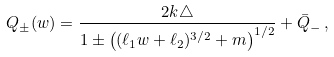<formula> <loc_0><loc_0><loc_500><loc_500>Q _ { \pm } ( w ) = \frac { 2 k \triangle } { 1 \pm \left ( ( \ell _ { 1 } w + \ell _ { 2 } ) ^ { 3 / 2 } + m \right ) ^ { 1 / 2 } } + \bar { Q } _ { - } \, ,</formula> 